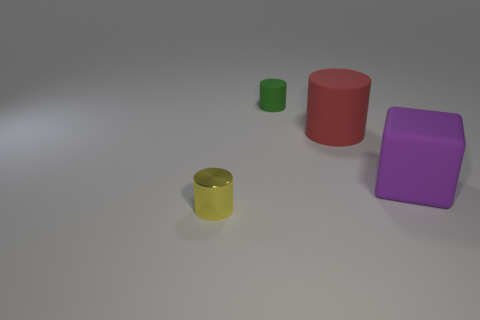Do the object that is in front of the purple cube and the red matte object have the same size?
Your answer should be compact. No. How many metallic things are in front of the small thing that is behind the thing that is to the left of the green matte cylinder?
Make the answer very short. 1. How many gray objects are either tiny rubber cylinders or small metallic cylinders?
Keep it short and to the point. 0. There is a large cylinder that is made of the same material as the cube; what is its color?
Provide a succinct answer. Red. Are there any other things that are the same size as the green cylinder?
Keep it short and to the point. Yes. What number of tiny things are green cylinders or matte blocks?
Give a very brief answer. 1. Are there fewer yellow shiny cylinders than small matte blocks?
Give a very brief answer. No. What is the color of the large rubber thing that is the same shape as the tiny metallic object?
Give a very brief answer. Red. Is there anything else that is the same shape as the tiny yellow metallic object?
Give a very brief answer. Yes. Is the number of big gray rubber cubes greater than the number of tiny yellow metallic objects?
Give a very brief answer. No. 